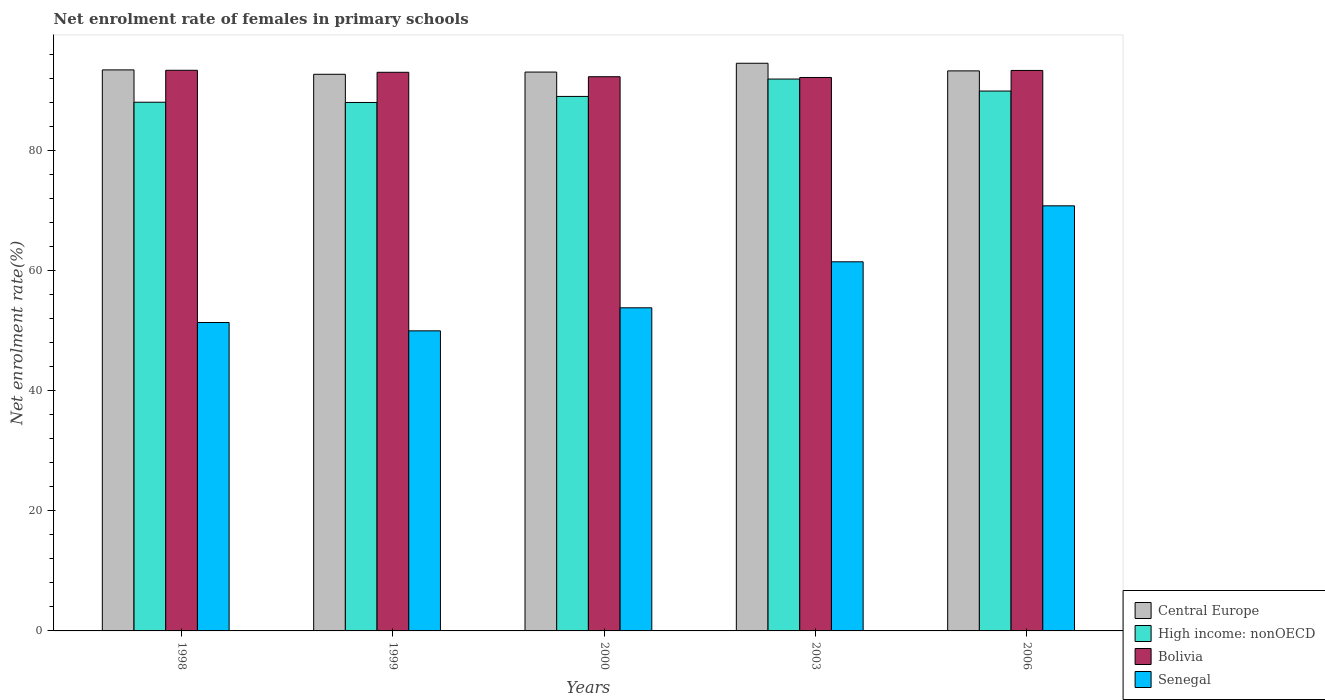How many different coloured bars are there?
Offer a terse response. 4. How many groups of bars are there?
Give a very brief answer. 5. Are the number of bars per tick equal to the number of legend labels?
Your response must be concise. Yes. How many bars are there on the 1st tick from the left?
Make the answer very short. 4. How many bars are there on the 2nd tick from the right?
Offer a very short reply. 4. What is the label of the 2nd group of bars from the left?
Keep it short and to the point. 1999. In how many cases, is the number of bars for a given year not equal to the number of legend labels?
Your answer should be very brief. 0. What is the net enrolment rate of females in primary schools in High income: nonOECD in 1998?
Make the answer very short. 88.06. Across all years, what is the maximum net enrolment rate of females in primary schools in Bolivia?
Keep it short and to the point. 93.38. Across all years, what is the minimum net enrolment rate of females in primary schools in Central Europe?
Ensure brevity in your answer.  92.71. In which year was the net enrolment rate of females in primary schools in Bolivia minimum?
Your answer should be compact. 2003. What is the total net enrolment rate of females in primary schools in Bolivia in the graph?
Offer a very short reply. 464.26. What is the difference between the net enrolment rate of females in primary schools in Bolivia in 2000 and that in 2003?
Offer a terse response. 0.12. What is the difference between the net enrolment rate of females in primary schools in Central Europe in 2000 and the net enrolment rate of females in primary schools in High income: nonOECD in 2003?
Your answer should be very brief. 1.16. What is the average net enrolment rate of females in primary schools in Senegal per year?
Offer a terse response. 57.49. In the year 1999, what is the difference between the net enrolment rate of females in primary schools in Bolivia and net enrolment rate of females in primary schools in High income: nonOECD?
Give a very brief answer. 5.03. What is the ratio of the net enrolment rate of females in primary schools in Central Europe in 2000 to that in 2003?
Offer a terse response. 0.98. Is the net enrolment rate of females in primary schools in Senegal in 1998 less than that in 2003?
Your response must be concise. Yes. What is the difference between the highest and the second highest net enrolment rate of females in primary schools in Senegal?
Make the answer very short. 9.33. What is the difference between the highest and the lowest net enrolment rate of females in primary schools in Senegal?
Your response must be concise. 20.82. In how many years, is the net enrolment rate of females in primary schools in Senegal greater than the average net enrolment rate of females in primary schools in Senegal taken over all years?
Ensure brevity in your answer.  2. Is it the case that in every year, the sum of the net enrolment rate of females in primary schools in High income: nonOECD and net enrolment rate of females in primary schools in Central Europe is greater than the sum of net enrolment rate of females in primary schools in Bolivia and net enrolment rate of females in primary schools in Senegal?
Give a very brief answer. Yes. What does the 4th bar from the left in 1999 represents?
Keep it short and to the point. Senegal. What does the 1st bar from the right in 1998 represents?
Offer a terse response. Senegal. Is it the case that in every year, the sum of the net enrolment rate of females in primary schools in Central Europe and net enrolment rate of females in primary schools in High income: nonOECD is greater than the net enrolment rate of females in primary schools in Senegal?
Provide a succinct answer. Yes. How many bars are there?
Keep it short and to the point. 20. Are all the bars in the graph horizontal?
Ensure brevity in your answer.  No. How many years are there in the graph?
Offer a terse response. 5. What is the difference between two consecutive major ticks on the Y-axis?
Your answer should be very brief. 20. Are the values on the major ticks of Y-axis written in scientific E-notation?
Keep it short and to the point. No. Where does the legend appear in the graph?
Offer a very short reply. Bottom right. How many legend labels are there?
Ensure brevity in your answer.  4. How are the legend labels stacked?
Ensure brevity in your answer.  Vertical. What is the title of the graph?
Your response must be concise. Net enrolment rate of females in primary schools. Does "Japan" appear as one of the legend labels in the graph?
Offer a terse response. No. What is the label or title of the X-axis?
Offer a terse response. Years. What is the label or title of the Y-axis?
Your response must be concise. Net enrolment rate(%). What is the Net enrolment rate(%) of Central Europe in 1998?
Offer a terse response. 93.44. What is the Net enrolment rate(%) in High income: nonOECD in 1998?
Offer a very short reply. 88.06. What is the Net enrolment rate(%) in Bolivia in 1998?
Offer a terse response. 93.38. What is the Net enrolment rate(%) of Senegal in 1998?
Your answer should be compact. 51.37. What is the Net enrolment rate(%) in Central Europe in 1999?
Your response must be concise. 92.71. What is the Net enrolment rate(%) of High income: nonOECD in 1999?
Your response must be concise. 88.02. What is the Net enrolment rate(%) in Bolivia in 1999?
Keep it short and to the point. 93.04. What is the Net enrolment rate(%) of Senegal in 1999?
Provide a short and direct response. 49.98. What is the Net enrolment rate(%) in Central Europe in 2000?
Ensure brevity in your answer.  93.08. What is the Net enrolment rate(%) of High income: nonOECD in 2000?
Make the answer very short. 89.02. What is the Net enrolment rate(%) in Bolivia in 2000?
Your answer should be compact. 92.3. What is the Net enrolment rate(%) in Senegal in 2000?
Provide a short and direct response. 53.82. What is the Net enrolment rate(%) in Central Europe in 2003?
Give a very brief answer. 94.55. What is the Net enrolment rate(%) of High income: nonOECD in 2003?
Your response must be concise. 91.92. What is the Net enrolment rate(%) of Bolivia in 2003?
Provide a short and direct response. 92.18. What is the Net enrolment rate(%) of Senegal in 2003?
Your answer should be very brief. 61.48. What is the Net enrolment rate(%) of Central Europe in 2006?
Provide a succinct answer. 93.28. What is the Net enrolment rate(%) in High income: nonOECD in 2006?
Offer a terse response. 89.92. What is the Net enrolment rate(%) in Bolivia in 2006?
Your answer should be compact. 93.35. What is the Net enrolment rate(%) in Senegal in 2006?
Ensure brevity in your answer.  70.8. Across all years, what is the maximum Net enrolment rate(%) of Central Europe?
Offer a terse response. 94.55. Across all years, what is the maximum Net enrolment rate(%) of High income: nonOECD?
Give a very brief answer. 91.92. Across all years, what is the maximum Net enrolment rate(%) in Bolivia?
Offer a very short reply. 93.38. Across all years, what is the maximum Net enrolment rate(%) of Senegal?
Your response must be concise. 70.8. Across all years, what is the minimum Net enrolment rate(%) in Central Europe?
Your response must be concise. 92.71. Across all years, what is the minimum Net enrolment rate(%) of High income: nonOECD?
Offer a terse response. 88.02. Across all years, what is the minimum Net enrolment rate(%) of Bolivia?
Make the answer very short. 92.18. Across all years, what is the minimum Net enrolment rate(%) of Senegal?
Give a very brief answer. 49.98. What is the total Net enrolment rate(%) in Central Europe in the graph?
Provide a succinct answer. 467.06. What is the total Net enrolment rate(%) in High income: nonOECD in the graph?
Your answer should be very brief. 446.94. What is the total Net enrolment rate(%) in Bolivia in the graph?
Your response must be concise. 464.26. What is the total Net enrolment rate(%) in Senegal in the graph?
Ensure brevity in your answer.  287.45. What is the difference between the Net enrolment rate(%) of Central Europe in 1998 and that in 1999?
Ensure brevity in your answer.  0.73. What is the difference between the Net enrolment rate(%) in High income: nonOECD in 1998 and that in 1999?
Provide a succinct answer. 0.04. What is the difference between the Net enrolment rate(%) in Bolivia in 1998 and that in 1999?
Provide a succinct answer. 0.34. What is the difference between the Net enrolment rate(%) in Senegal in 1998 and that in 1999?
Your response must be concise. 1.39. What is the difference between the Net enrolment rate(%) of Central Europe in 1998 and that in 2000?
Provide a short and direct response. 0.36. What is the difference between the Net enrolment rate(%) of High income: nonOECD in 1998 and that in 2000?
Provide a succinct answer. -0.97. What is the difference between the Net enrolment rate(%) in Bolivia in 1998 and that in 2000?
Make the answer very short. 1.07. What is the difference between the Net enrolment rate(%) in Senegal in 1998 and that in 2000?
Keep it short and to the point. -2.45. What is the difference between the Net enrolment rate(%) in Central Europe in 1998 and that in 2003?
Provide a short and direct response. -1.1. What is the difference between the Net enrolment rate(%) in High income: nonOECD in 1998 and that in 2003?
Offer a very short reply. -3.86. What is the difference between the Net enrolment rate(%) in Bolivia in 1998 and that in 2003?
Keep it short and to the point. 1.2. What is the difference between the Net enrolment rate(%) in Senegal in 1998 and that in 2003?
Your answer should be very brief. -10.11. What is the difference between the Net enrolment rate(%) of Central Europe in 1998 and that in 2006?
Offer a terse response. 0.17. What is the difference between the Net enrolment rate(%) in High income: nonOECD in 1998 and that in 2006?
Offer a very short reply. -1.86. What is the difference between the Net enrolment rate(%) in Bolivia in 1998 and that in 2006?
Provide a succinct answer. 0.03. What is the difference between the Net enrolment rate(%) in Senegal in 1998 and that in 2006?
Offer a very short reply. -19.44. What is the difference between the Net enrolment rate(%) in Central Europe in 1999 and that in 2000?
Give a very brief answer. -0.37. What is the difference between the Net enrolment rate(%) in High income: nonOECD in 1999 and that in 2000?
Ensure brevity in your answer.  -1.01. What is the difference between the Net enrolment rate(%) of Bolivia in 1999 and that in 2000?
Make the answer very short. 0.74. What is the difference between the Net enrolment rate(%) of Senegal in 1999 and that in 2000?
Provide a short and direct response. -3.84. What is the difference between the Net enrolment rate(%) in Central Europe in 1999 and that in 2003?
Offer a terse response. -1.84. What is the difference between the Net enrolment rate(%) in High income: nonOECD in 1999 and that in 2003?
Give a very brief answer. -3.9. What is the difference between the Net enrolment rate(%) of Bolivia in 1999 and that in 2003?
Make the answer very short. 0.86. What is the difference between the Net enrolment rate(%) in Senegal in 1999 and that in 2003?
Ensure brevity in your answer.  -11.5. What is the difference between the Net enrolment rate(%) of Central Europe in 1999 and that in 2006?
Keep it short and to the point. -0.57. What is the difference between the Net enrolment rate(%) in High income: nonOECD in 1999 and that in 2006?
Make the answer very short. -1.9. What is the difference between the Net enrolment rate(%) of Bolivia in 1999 and that in 2006?
Your answer should be compact. -0.31. What is the difference between the Net enrolment rate(%) in Senegal in 1999 and that in 2006?
Offer a very short reply. -20.82. What is the difference between the Net enrolment rate(%) of Central Europe in 2000 and that in 2003?
Provide a succinct answer. -1.47. What is the difference between the Net enrolment rate(%) of High income: nonOECD in 2000 and that in 2003?
Make the answer very short. -2.9. What is the difference between the Net enrolment rate(%) in Bolivia in 2000 and that in 2003?
Keep it short and to the point. 0.12. What is the difference between the Net enrolment rate(%) in Senegal in 2000 and that in 2003?
Your answer should be compact. -7.66. What is the difference between the Net enrolment rate(%) in Central Europe in 2000 and that in 2006?
Provide a succinct answer. -0.2. What is the difference between the Net enrolment rate(%) in High income: nonOECD in 2000 and that in 2006?
Make the answer very short. -0.9. What is the difference between the Net enrolment rate(%) in Bolivia in 2000 and that in 2006?
Ensure brevity in your answer.  -1.05. What is the difference between the Net enrolment rate(%) of Senegal in 2000 and that in 2006?
Your response must be concise. -16.99. What is the difference between the Net enrolment rate(%) of Central Europe in 2003 and that in 2006?
Your answer should be very brief. 1.27. What is the difference between the Net enrolment rate(%) in High income: nonOECD in 2003 and that in 2006?
Offer a terse response. 2. What is the difference between the Net enrolment rate(%) of Bolivia in 2003 and that in 2006?
Your response must be concise. -1.17. What is the difference between the Net enrolment rate(%) in Senegal in 2003 and that in 2006?
Your response must be concise. -9.33. What is the difference between the Net enrolment rate(%) in Central Europe in 1998 and the Net enrolment rate(%) in High income: nonOECD in 1999?
Make the answer very short. 5.43. What is the difference between the Net enrolment rate(%) in Central Europe in 1998 and the Net enrolment rate(%) in Bolivia in 1999?
Make the answer very short. 0.4. What is the difference between the Net enrolment rate(%) in Central Europe in 1998 and the Net enrolment rate(%) in Senegal in 1999?
Provide a short and direct response. 43.46. What is the difference between the Net enrolment rate(%) in High income: nonOECD in 1998 and the Net enrolment rate(%) in Bolivia in 1999?
Ensure brevity in your answer.  -4.99. What is the difference between the Net enrolment rate(%) of High income: nonOECD in 1998 and the Net enrolment rate(%) of Senegal in 1999?
Make the answer very short. 38.08. What is the difference between the Net enrolment rate(%) in Bolivia in 1998 and the Net enrolment rate(%) in Senegal in 1999?
Give a very brief answer. 43.4. What is the difference between the Net enrolment rate(%) in Central Europe in 1998 and the Net enrolment rate(%) in High income: nonOECD in 2000?
Provide a short and direct response. 4.42. What is the difference between the Net enrolment rate(%) in Central Europe in 1998 and the Net enrolment rate(%) in Bolivia in 2000?
Offer a terse response. 1.14. What is the difference between the Net enrolment rate(%) in Central Europe in 1998 and the Net enrolment rate(%) in Senegal in 2000?
Give a very brief answer. 39.63. What is the difference between the Net enrolment rate(%) in High income: nonOECD in 1998 and the Net enrolment rate(%) in Bolivia in 2000?
Offer a very short reply. -4.25. What is the difference between the Net enrolment rate(%) in High income: nonOECD in 1998 and the Net enrolment rate(%) in Senegal in 2000?
Provide a short and direct response. 34.24. What is the difference between the Net enrolment rate(%) in Bolivia in 1998 and the Net enrolment rate(%) in Senegal in 2000?
Your answer should be very brief. 39.56. What is the difference between the Net enrolment rate(%) of Central Europe in 1998 and the Net enrolment rate(%) of High income: nonOECD in 2003?
Offer a very short reply. 1.53. What is the difference between the Net enrolment rate(%) of Central Europe in 1998 and the Net enrolment rate(%) of Bolivia in 2003?
Ensure brevity in your answer.  1.26. What is the difference between the Net enrolment rate(%) of Central Europe in 1998 and the Net enrolment rate(%) of Senegal in 2003?
Keep it short and to the point. 31.97. What is the difference between the Net enrolment rate(%) in High income: nonOECD in 1998 and the Net enrolment rate(%) in Bolivia in 2003?
Your answer should be very brief. -4.12. What is the difference between the Net enrolment rate(%) of High income: nonOECD in 1998 and the Net enrolment rate(%) of Senegal in 2003?
Provide a succinct answer. 26.58. What is the difference between the Net enrolment rate(%) in Bolivia in 1998 and the Net enrolment rate(%) in Senegal in 2003?
Make the answer very short. 31.9. What is the difference between the Net enrolment rate(%) in Central Europe in 1998 and the Net enrolment rate(%) in High income: nonOECD in 2006?
Ensure brevity in your answer.  3.52. What is the difference between the Net enrolment rate(%) in Central Europe in 1998 and the Net enrolment rate(%) in Bolivia in 2006?
Provide a short and direct response. 0.09. What is the difference between the Net enrolment rate(%) of Central Europe in 1998 and the Net enrolment rate(%) of Senegal in 2006?
Your response must be concise. 22.64. What is the difference between the Net enrolment rate(%) in High income: nonOECD in 1998 and the Net enrolment rate(%) in Bolivia in 2006?
Make the answer very short. -5.29. What is the difference between the Net enrolment rate(%) in High income: nonOECD in 1998 and the Net enrolment rate(%) in Senegal in 2006?
Offer a very short reply. 17.25. What is the difference between the Net enrolment rate(%) of Bolivia in 1998 and the Net enrolment rate(%) of Senegal in 2006?
Offer a very short reply. 22.57. What is the difference between the Net enrolment rate(%) of Central Europe in 1999 and the Net enrolment rate(%) of High income: nonOECD in 2000?
Provide a succinct answer. 3.69. What is the difference between the Net enrolment rate(%) of Central Europe in 1999 and the Net enrolment rate(%) of Bolivia in 2000?
Provide a short and direct response. 0.41. What is the difference between the Net enrolment rate(%) of Central Europe in 1999 and the Net enrolment rate(%) of Senegal in 2000?
Your answer should be compact. 38.89. What is the difference between the Net enrolment rate(%) of High income: nonOECD in 1999 and the Net enrolment rate(%) of Bolivia in 2000?
Your response must be concise. -4.29. What is the difference between the Net enrolment rate(%) in High income: nonOECD in 1999 and the Net enrolment rate(%) in Senegal in 2000?
Offer a very short reply. 34.2. What is the difference between the Net enrolment rate(%) of Bolivia in 1999 and the Net enrolment rate(%) of Senegal in 2000?
Ensure brevity in your answer.  39.23. What is the difference between the Net enrolment rate(%) of Central Europe in 1999 and the Net enrolment rate(%) of High income: nonOECD in 2003?
Provide a short and direct response. 0.79. What is the difference between the Net enrolment rate(%) in Central Europe in 1999 and the Net enrolment rate(%) in Bolivia in 2003?
Give a very brief answer. 0.53. What is the difference between the Net enrolment rate(%) of Central Europe in 1999 and the Net enrolment rate(%) of Senegal in 2003?
Your response must be concise. 31.23. What is the difference between the Net enrolment rate(%) of High income: nonOECD in 1999 and the Net enrolment rate(%) of Bolivia in 2003?
Keep it short and to the point. -4.16. What is the difference between the Net enrolment rate(%) in High income: nonOECD in 1999 and the Net enrolment rate(%) in Senegal in 2003?
Offer a terse response. 26.54. What is the difference between the Net enrolment rate(%) of Bolivia in 1999 and the Net enrolment rate(%) of Senegal in 2003?
Offer a very short reply. 31.57. What is the difference between the Net enrolment rate(%) in Central Europe in 1999 and the Net enrolment rate(%) in High income: nonOECD in 2006?
Provide a short and direct response. 2.79. What is the difference between the Net enrolment rate(%) in Central Europe in 1999 and the Net enrolment rate(%) in Bolivia in 2006?
Provide a short and direct response. -0.64. What is the difference between the Net enrolment rate(%) of Central Europe in 1999 and the Net enrolment rate(%) of Senegal in 2006?
Give a very brief answer. 21.91. What is the difference between the Net enrolment rate(%) in High income: nonOECD in 1999 and the Net enrolment rate(%) in Bolivia in 2006?
Offer a very short reply. -5.33. What is the difference between the Net enrolment rate(%) of High income: nonOECD in 1999 and the Net enrolment rate(%) of Senegal in 2006?
Your answer should be very brief. 17.21. What is the difference between the Net enrolment rate(%) in Bolivia in 1999 and the Net enrolment rate(%) in Senegal in 2006?
Keep it short and to the point. 22.24. What is the difference between the Net enrolment rate(%) in Central Europe in 2000 and the Net enrolment rate(%) in High income: nonOECD in 2003?
Give a very brief answer. 1.16. What is the difference between the Net enrolment rate(%) in Central Europe in 2000 and the Net enrolment rate(%) in Bolivia in 2003?
Ensure brevity in your answer.  0.9. What is the difference between the Net enrolment rate(%) in Central Europe in 2000 and the Net enrolment rate(%) in Senegal in 2003?
Give a very brief answer. 31.6. What is the difference between the Net enrolment rate(%) in High income: nonOECD in 2000 and the Net enrolment rate(%) in Bolivia in 2003?
Your response must be concise. -3.16. What is the difference between the Net enrolment rate(%) in High income: nonOECD in 2000 and the Net enrolment rate(%) in Senegal in 2003?
Provide a succinct answer. 27.54. What is the difference between the Net enrolment rate(%) in Bolivia in 2000 and the Net enrolment rate(%) in Senegal in 2003?
Make the answer very short. 30.83. What is the difference between the Net enrolment rate(%) in Central Europe in 2000 and the Net enrolment rate(%) in High income: nonOECD in 2006?
Your answer should be compact. 3.16. What is the difference between the Net enrolment rate(%) of Central Europe in 2000 and the Net enrolment rate(%) of Bolivia in 2006?
Ensure brevity in your answer.  -0.27. What is the difference between the Net enrolment rate(%) of Central Europe in 2000 and the Net enrolment rate(%) of Senegal in 2006?
Your response must be concise. 22.28. What is the difference between the Net enrolment rate(%) of High income: nonOECD in 2000 and the Net enrolment rate(%) of Bolivia in 2006?
Provide a succinct answer. -4.33. What is the difference between the Net enrolment rate(%) in High income: nonOECD in 2000 and the Net enrolment rate(%) in Senegal in 2006?
Your answer should be compact. 18.22. What is the difference between the Net enrolment rate(%) in Bolivia in 2000 and the Net enrolment rate(%) in Senegal in 2006?
Keep it short and to the point. 21.5. What is the difference between the Net enrolment rate(%) of Central Europe in 2003 and the Net enrolment rate(%) of High income: nonOECD in 2006?
Give a very brief answer. 4.63. What is the difference between the Net enrolment rate(%) in Central Europe in 2003 and the Net enrolment rate(%) in Bolivia in 2006?
Keep it short and to the point. 1.2. What is the difference between the Net enrolment rate(%) in Central Europe in 2003 and the Net enrolment rate(%) in Senegal in 2006?
Make the answer very short. 23.74. What is the difference between the Net enrolment rate(%) of High income: nonOECD in 2003 and the Net enrolment rate(%) of Bolivia in 2006?
Offer a terse response. -1.43. What is the difference between the Net enrolment rate(%) of High income: nonOECD in 2003 and the Net enrolment rate(%) of Senegal in 2006?
Offer a very short reply. 21.11. What is the difference between the Net enrolment rate(%) of Bolivia in 2003 and the Net enrolment rate(%) of Senegal in 2006?
Your response must be concise. 21.38. What is the average Net enrolment rate(%) of Central Europe per year?
Your answer should be compact. 93.41. What is the average Net enrolment rate(%) of High income: nonOECD per year?
Your response must be concise. 89.39. What is the average Net enrolment rate(%) of Bolivia per year?
Make the answer very short. 92.85. What is the average Net enrolment rate(%) of Senegal per year?
Your answer should be very brief. 57.49. In the year 1998, what is the difference between the Net enrolment rate(%) of Central Europe and Net enrolment rate(%) of High income: nonOECD?
Offer a very short reply. 5.39. In the year 1998, what is the difference between the Net enrolment rate(%) in Central Europe and Net enrolment rate(%) in Bolivia?
Provide a succinct answer. 0.07. In the year 1998, what is the difference between the Net enrolment rate(%) in Central Europe and Net enrolment rate(%) in Senegal?
Keep it short and to the point. 42.08. In the year 1998, what is the difference between the Net enrolment rate(%) of High income: nonOECD and Net enrolment rate(%) of Bolivia?
Your answer should be very brief. -5.32. In the year 1998, what is the difference between the Net enrolment rate(%) in High income: nonOECD and Net enrolment rate(%) in Senegal?
Ensure brevity in your answer.  36.69. In the year 1998, what is the difference between the Net enrolment rate(%) of Bolivia and Net enrolment rate(%) of Senegal?
Provide a short and direct response. 42.01. In the year 1999, what is the difference between the Net enrolment rate(%) in Central Europe and Net enrolment rate(%) in High income: nonOECD?
Your answer should be compact. 4.69. In the year 1999, what is the difference between the Net enrolment rate(%) in Central Europe and Net enrolment rate(%) in Bolivia?
Keep it short and to the point. -0.33. In the year 1999, what is the difference between the Net enrolment rate(%) in Central Europe and Net enrolment rate(%) in Senegal?
Make the answer very short. 42.73. In the year 1999, what is the difference between the Net enrolment rate(%) of High income: nonOECD and Net enrolment rate(%) of Bolivia?
Ensure brevity in your answer.  -5.03. In the year 1999, what is the difference between the Net enrolment rate(%) of High income: nonOECD and Net enrolment rate(%) of Senegal?
Your answer should be compact. 38.04. In the year 1999, what is the difference between the Net enrolment rate(%) in Bolivia and Net enrolment rate(%) in Senegal?
Make the answer very short. 43.06. In the year 2000, what is the difference between the Net enrolment rate(%) of Central Europe and Net enrolment rate(%) of High income: nonOECD?
Give a very brief answer. 4.06. In the year 2000, what is the difference between the Net enrolment rate(%) in Central Europe and Net enrolment rate(%) in Bolivia?
Keep it short and to the point. 0.78. In the year 2000, what is the difference between the Net enrolment rate(%) in Central Europe and Net enrolment rate(%) in Senegal?
Offer a terse response. 39.26. In the year 2000, what is the difference between the Net enrolment rate(%) in High income: nonOECD and Net enrolment rate(%) in Bolivia?
Provide a short and direct response. -3.28. In the year 2000, what is the difference between the Net enrolment rate(%) in High income: nonOECD and Net enrolment rate(%) in Senegal?
Make the answer very short. 35.21. In the year 2000, what is the difference between the Net enrolment rate(%) in Bolivia and Net enrolment rate(%) in Senegal?
Make the answer very short. 38.49. In the year 2003, what is the difference between the Net enrolment rate(%) of Central Europe and Net enrolment rate(%) of High income: nonOECD?
Ensure brevity in your answer.  2.63. In the year 2003, what is the difference between the Net enrolment rate(%) of Central Europe and Net enrolment rate(%) of Bolivia?
Ensure brevity in your answer.  2.37. In the year 2003, what is the difference between the Net enrolment rate(%) of Central Europe and Net enrolment rate(%) of Senegal?
Your response must be concise. 33.07. In the year 2003, what is the difference between the Net enrolment rate(%) of High income: nonOECD and Net enrolment rate(%) of Bolivia?
Your answer should be compact. -0.26. In the year 2003, what is the difference between the Net enrolment rate(%) in High income: nonOECD and Net enrolment rate(%) in Senegal?
Offer a terse response. 30.44. In the year 2003, what is the difference between the Net enrolment rate(%) of Bolivia and Net enrolment rate(%) of Senegal?
Give a very brief answer. 30.7. In the year 2006, what is the difference between the Net enrolment rate(%) in Central Europe and Net enrolment rate(%) in High income: nonOECD?
Ensure brevity in your answer.  3.36. In the year 2006, what is the difference between the Net enrolment rate(%) of Central Europe and Net enrolment rate(%) of Bolivia?
Give a very brief answer. -0.07. In the year 2006, what is the difference between the Net enrolment rate(%) of Central Europe and Net enrolment rate(%) of Senegal?
Keep it short and to the point. 22.47. In the year 2006, what is the difference between the Net enrolment rate(%) in High income: nonOECD and Net enrolment rate(%) in Bolivia?
Keep it short and to the point. -3.43. In the year 2006, what is the difference between the Net enrolment rate(%) of High income: nonOECD and Net enrolment rate(%) of Senegal?
Your answer should be very brief. 19.12. In the year 2006, what is the difference between the Net enrolment rate(%) of Bolivia and Net enrolment rate(%) of Senegal?
Offer a very short reply. 22.55. What is the ratio of the Net enrolment rate(%) of Central Europe in 1998 to that in 1999?
Provide a short and direct response. 1.01. What is the ratio of the Net enrolment rate(%) in Senegal in 1998 to that in 1999?
Offer a very short reply. 1.03. What is the ratio of the Net enrolment rate(%) in Bolivia in 1998 to that in 2000?
Offer a terse response. 1.01. What is the ratio of the Net enrolment rate(%) in Senegal in 1998 to that in 2000?
Provide a succinct answer. 0.95. What is the ratio of the Net enrolment rate(%) of Central Europe in 1998 to that in 2003?
Offer a terse response. 0.99. What is the ratio of the Net enrolment rate(%) of High income: nonOECD in 1998 to that in 2003?
Your response must be concise. 0.96. What is the ratio of the Net enrolment rate(%) of Bolivia in 1998 to that in 2003?
Offer a terse response. 1.01. What is the ratio of the Net enrolment rate(%) in Senegal in 1998 to that in 2003?
Offer a terse response. 0.84. What is the ratio of the Net enrolment rate(%) in Central Europe in 1998 to that in 2006?
Give a very brief answer. 1. What is the ratio of the Net enrolment rate(%) in High income: nonOECD in 1998 to that in 2006?
Ensure brevity in your answer.  0.98. What is the ratio of the Net enrolment rate(%) in Senegal in 1998 to that in 2006?
Keep it short and to the point. 0.73. What is the ratio of the Net enrolment rate(%) of High income: nonOECD in 1999 to that in 2000?
Provide a short and direct response. 0.99. What is the ratio of the Net enrolment rate(%) of Bolivia in 1999 to that in 2000?
Ensure brevity in your answer.  1.01. What is the ratio of the Net enrolment rate(%) of Senegal in 1999 to that in 2000?
Your answer should be compact. 0.93. What is the ratio of the Net enrolment rate(%) in Central Europe in 1999 to that in 2003?
Make the answer very short. 0.98. What is the ratio of the Net enrolment rate(%) in High income: nonOECD in 1999 to that in 2003?
Provide a succinct answer. 0.96. What is the ratio of the Net enrolment rate(%) in Bolivia in 1999 to that in 2003?
Give a very brief answer. 1.01. What is the ratio of the Net enrolment rate(%) of Senegal in 1999 to that in 2003?
Give a very brief answer. 0.81. What is the ratio of the Net enrolment rate(%) of High income: nonOECD in 1999 to that in 2006?
Provide a short and direct response. 0.98. What is the ratio of the Net enrolment rate(%) of Bolivia in 1999 to that in 2006?
Your answer should be compact. 1. What is the ratio of the Net enrolment rate(%) in Senegal in 1999 to that in 2006?
Your response must be concise. 0.71. What is the ratio of the Net enrolment rate(%) in Central Europe in 2000 to that in 2003?
Give a very brief answer. 0.98. What is the ratio of the Net enrolment rate(%) in High income: nonOECD in 2000 to that in 2003?
Keep it short and to the point. 0.97. What is the ratio of the Net enrolment rate(%) in Senegal in 2000 to that in 2003?
Offer a terse response. 0.88. What is the ratio of the Net enrolment rate(%) in Central Europe in 2000 to that in 2006?
Ensure brevity in your answer.  1. What is the ratio of the Net enrolment rate(%) in High income: nonOECD in 2000 to that in 2006?
Provide a succinct answer. 0.99. What is the ratio of the Net enrolment rate(%) of Senegal in 2000 to that in 2006?
Offer a terse response. 0.76. What is the ratio of the Net enrolment rate(%) of Central Europe in 2003 to that in 2006?
Provide a succinct answer. 1.01. What is the ratio of the Net enrolment rate(%) of High income: nonOECD in 2003 to that in 2006?
Offer a terse response. 1.02. What is the ratio of the Net enrolment rate(%) of Bolivia in 2003 to that in 2006?
Keep it short and to the point. 0.99. What is the ratio of the Net enrolment rate(%) in Senegal in 2003 to that in 2006?
Offer a terse response. 0.87. What is the difference between the highest and the second highest Net enrolment rate(%) of Central Europe?
Provide a short and direct response. 1.1. What is the difference between the highest and the second highest Net enrolment rate(%) of High income: nonOECD?
Keep it short and to the point. 2. What is the difference between the highest and the second highest Net enrolment rate(%) of Bolivia?
Give a very brief answer. 0.03. What is the difference between the highest and the second highest Net enrolment rate(%) of Senegal?
Ensure brevity in your answer.  9.33. What is the difference between the highest and the lowest Net enrolment rate(%) in Central Europe?
Provide a succinct answer. 1.84. What is the difference between the highest and the lowest Net enrolment rate(%) of High income: nonOECD?
Offer a terse response. 3.9. What is the difference between the highest and the lowest Net enrolment rate(%) of Bolivia?
Your response must be concise. 1.2. What is the difference between the highest and the lowest Net enrolment rate(%) in Senegal?
Provide a short and direct response. 20.82. 